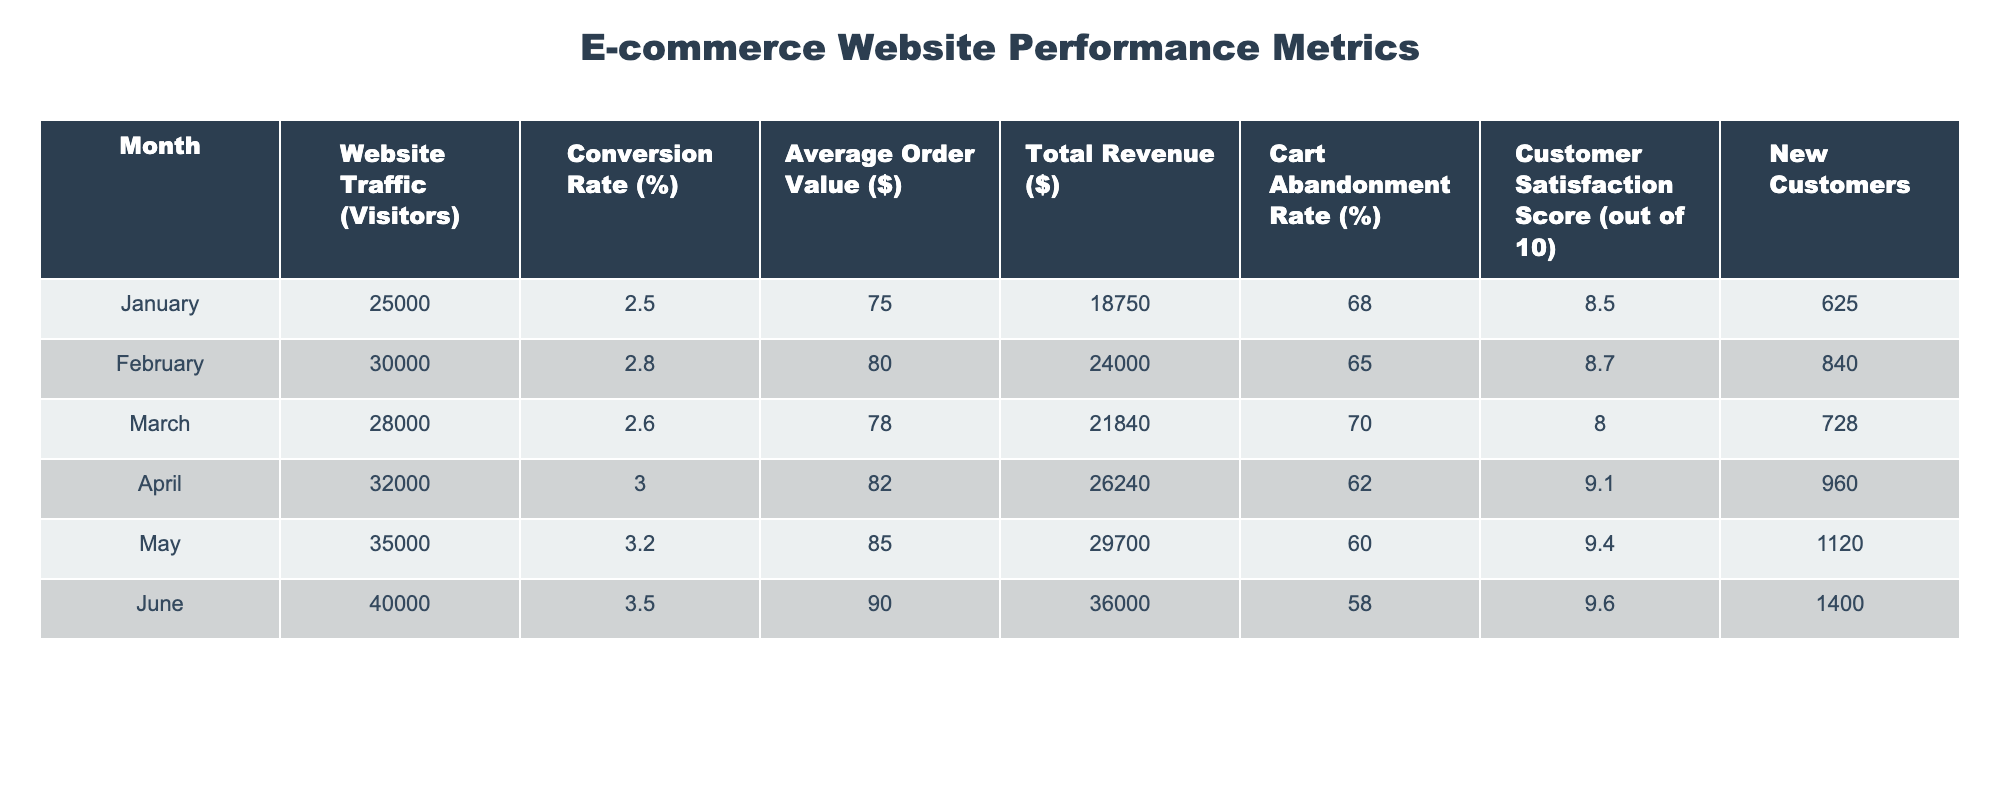What's the total revenue for May? The total revenue for May is directly listed in the table under the 'Total Revenue ($)' column for that month. It shows a value of $29,700.
Answer: 29,700 What was the website traffic in April? The website traffic for April is found in the 'Website Traffic (Visitors)' column corresponding to April in the table. The value is 32,000 visitors.
Answer: 32,000 Is the average order value highest in June? To answer this, we check the 'Average Order Value ($)' for each month. The average order value for June is $90, which is higher than the values for any other month listed.
Answer: Yes What is the average customer satisfaction score over the six months? First, we sum the customer satisfaction scores from each month: 8.5 + 8.7 + 8.0 + 9.1 + 9.4 + 9.6 = 53.3. Then, we divide by the number of months, which is 6. So, 53.3 / 6 = 8.8833, rounding to one decimal place gives 8.9.
Answer: 8.9 What month had the lowest conversion rate, and what was it? We examine the 'Conversion Rate (%)' for each month and find that January has the lowest value at 2.5%.
Answer: January, 2.5% Which month had the most new customers? We review the 'New Customers' column to find that June had the highest value, which is 1,400 new customers.
Answer: June, 1,400 Was the cart abandonment rate lowest in June? Checking the 'Cart Abandonment Rate (%)' for each month reveals that June has the lowest rate at 58%, compared to other months’ rates.
Answer: Yes What is the increase in total revenue from January to June? We find the total revenue for January ($18,750) and for June ($36,000). The increase is 36,000 - 18,750 = 17,250.
Answer: 17,250 Which month had the highest increase in website traffic compared to the previous month? We look at the website traffic values month by month: January (25,000) to February (30,000) is an increase of 5,000, February to March (28,000) is a decrease, and so on. The highest increase is from May (35,000) to June (40,000), an increase of 5,000 visitors.
Answer: June (5,000 increase) 